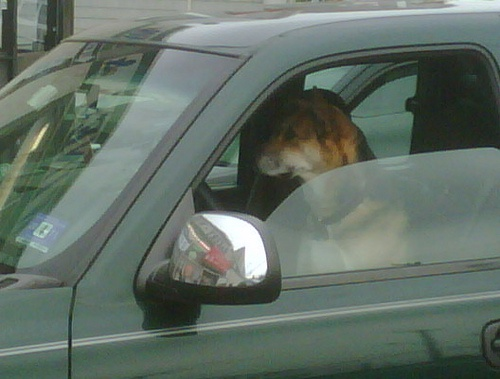Describe the objects in this image and their specific colors. I can see car in gray, darkgray, and black tones and dog in gray, darkgray, and black tones in this image. 